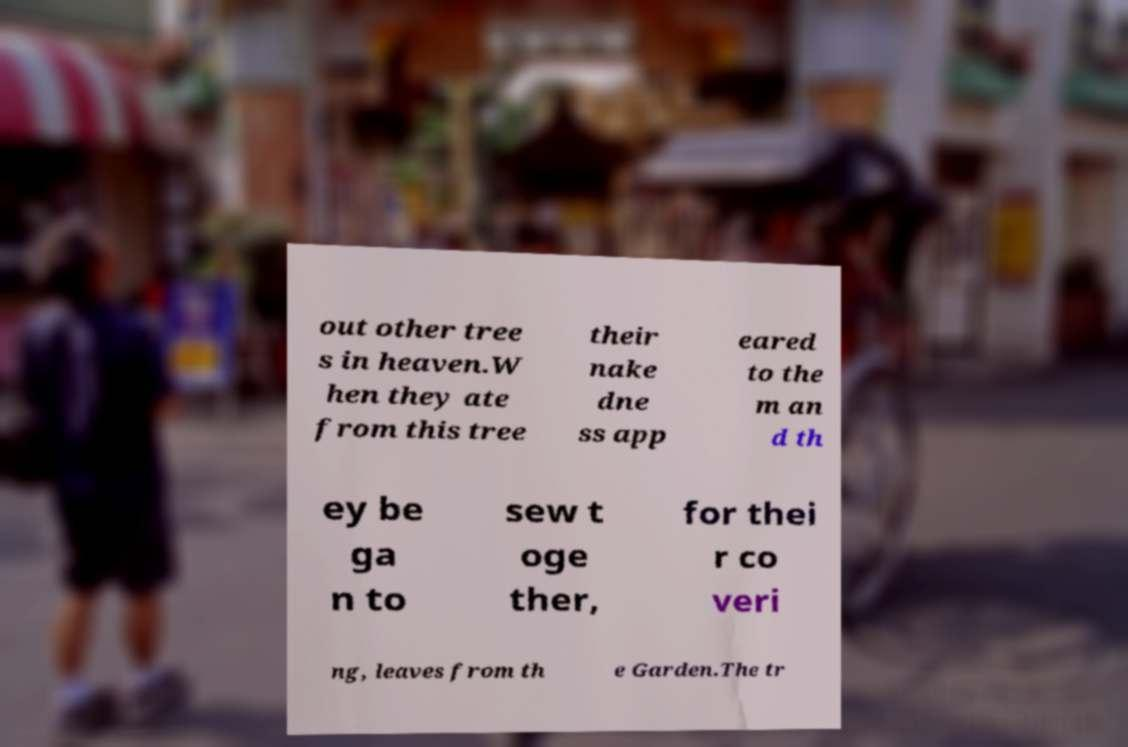Could you extract and type out the text from this image? out other tree s in heaven.W hen they ate from this tree their nake dne ss app eared to the m an d th ey be ga n to sew t oge ther, for thei r co veri ng, leaves from th e Garden.The tr 